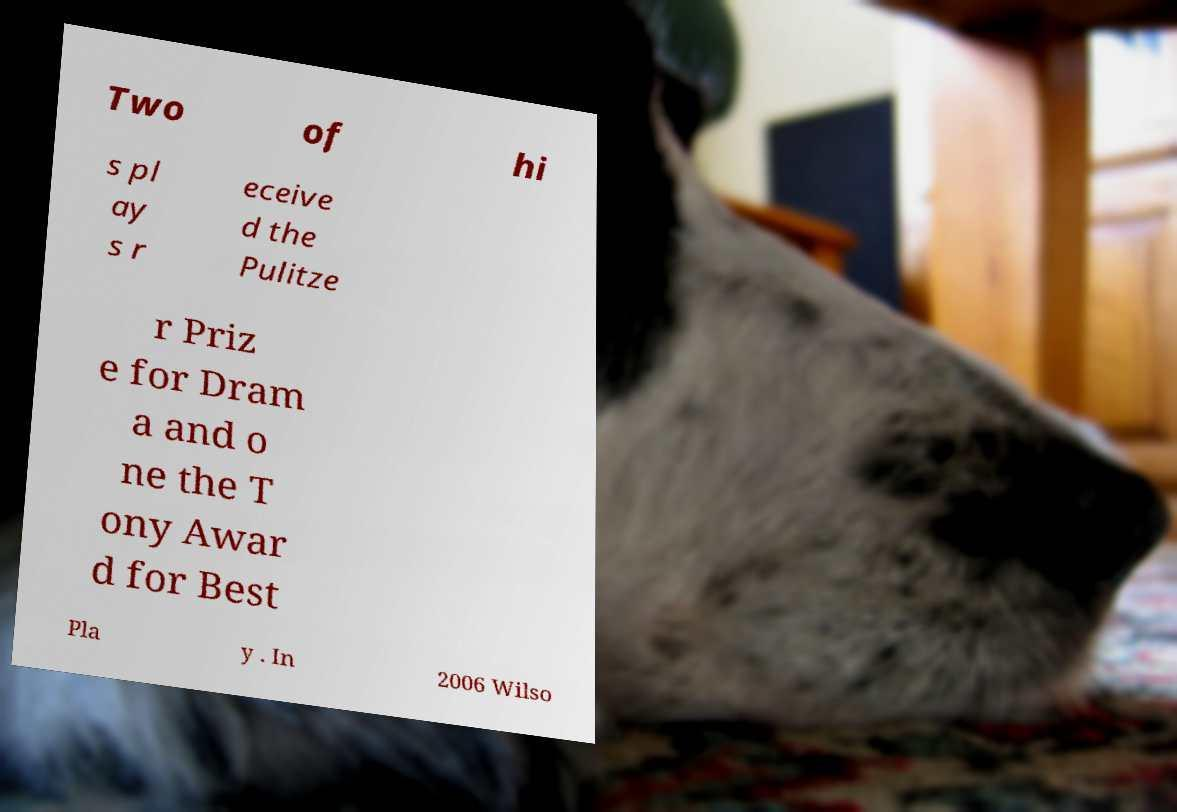Could you extract and type out the text from this image? Two of hi s pl ay s r eceive d the Pulitze r Priz e for Dram a and o ne the T ony Awar d for Best Pla y . In 2006 Wilso 